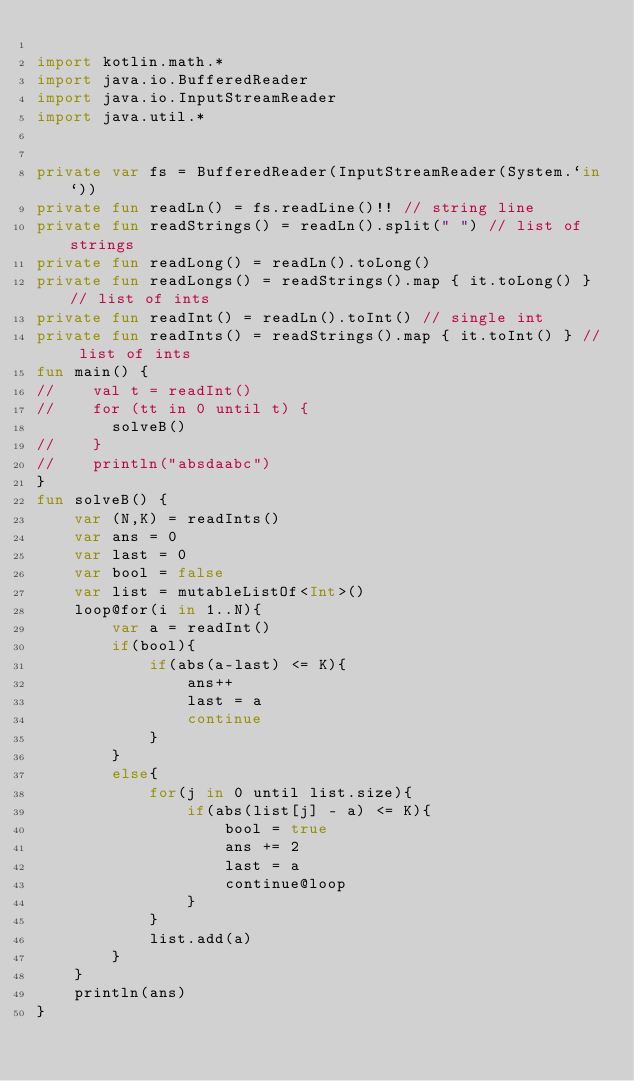<code> <loc_0><loc_0><loc_500><loc_500><_Kotlin_>
import kotlin.math.*
import java.io.BufferedReader
import java.io.InputStreamReader
import java.util.*


private var fs = BufferedReader(InputStreamReader(System.`in`))
private fun readLn() = fs.readLine()!! // string line
private fun readStrings() = readLn().split(" ") // list of strings
private fun readLong() = readLn().toLong()
private fun readLongs() = readStrings().map { it.toLong() } // list of ints
private fun readInt() = readLn().toInt() // single int
private fun readInts() = readStrings().map { it.toInt() } // list of ints
fun main() {
//    val t = readInt()
//    for (tt in 0 until t) {
        solveB()
//    }
//    println("absdaabc")
}
fun solveB() {
    var (N,K) = readInts()
    var ans = 0
    var last = 0
    var bool = false
    var list = mutableListOf<Int>()
    loop@for(i in 1..N){
        var a = readInt()
        if(bool){
            if(abs(a-last) <= K){
                ans++
                last = a
                continue
            }
        }
        else{
            for(j in 0 until list.size){
                if(abs(list[j] - a) <= K){
                    bool = true
                    ans += 2
                    last = a
                    continue@loop
                }
            }
            list.add(a)
        }
    }
    println(ans)
}</code> 